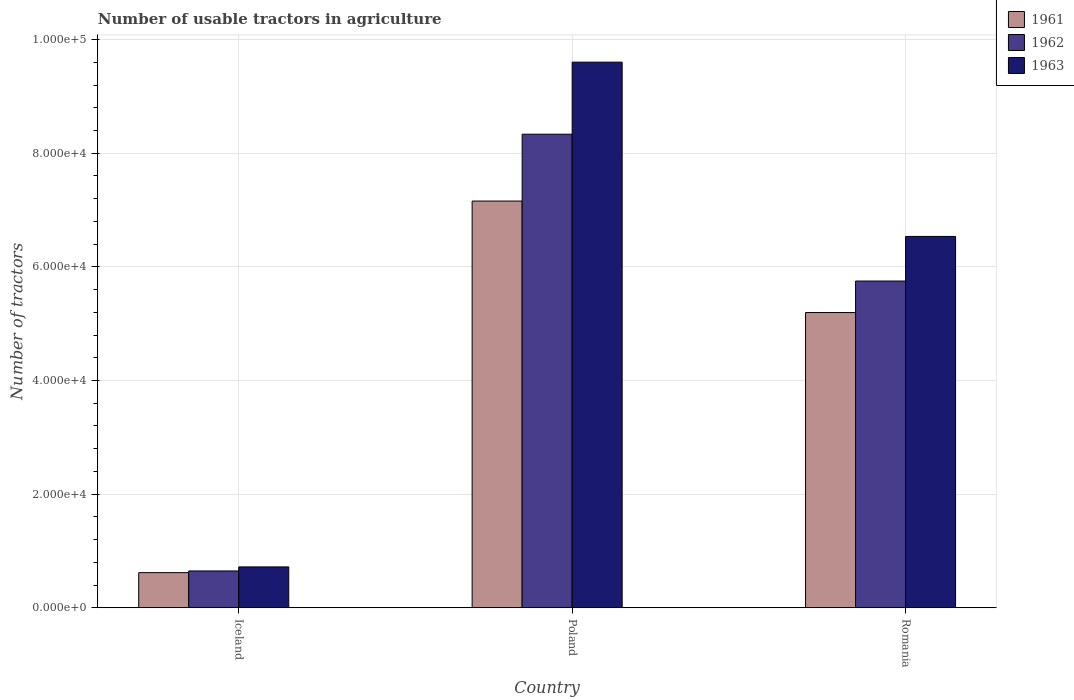Are the number of bars per tick equal to the number of legend labels?
Make the answer very short. Yes. Are the number of bars on each tick of the X-axis equal?
Give a very brief answer. Yes. How many bars are there on the 3rd tick from the left?
Offer a very short reply. 3. What is the label of the 3rd group of bars from the left?
Provide a succinct answer. Romania. What is the number of usable tractors in agriculture in 1963 in Poland?
Your answer should be compact. 9.60e+04. Across all countries, what is the maximum number of usable tractors in agriculture in 1963?
Make the answer very short. 9.60e+04. Across all countries, what is the minimum number of usable tractors in agriculture in 1963?
Your response must be concise. 7187. In which country was the number of usable tractors in agriculture in 1963 maximum?
Provide a succinct answer. Poland. In which country was the number of usable tractors in agriculture in 1961 minimum?
Make the answer very short. Iceland. What is the total number of usable tractors in agriculture in 1962 in the graph?
Your response must be concise. 1.47e+05. What is the difference between the number of usable tractors in agriculture in 1963 in Iceland and that in Poland?
Offer a very short reply. -8.88e+04. What is the difference between the number of usable tractors in agriculture in 1963 in Poland and the number of usable tractors in agriculture in 1961 in Romania?
Offer a very short reply. 4.41e+04. What is the average number of usable tractors in agriculture in 1962 per country?
Give a very brief answer. 4.91e+04. What is the difference between the number of usable tractors in agriculture of/in 1963 and number of usable tractors in agriculture of/in 1962 in Romania?
Make the answer very short. 7851. What is the ratio of the number of usable tractors in agriculture in 1963 in Poland to that in Romania?
Your answer should be compact. 1.47. Is the number of usable tractors in agriculture in 1963 in Iceland less than that in Poland?
Your response must be concise. Yes. Is the difference between the number of usable tractors in agriculture in 1963 in Poland and Romania greater than the difference between the number of usable tractors in agriculture in 1962 in Poland and Romania?
Give a very brief answer. Yes. What is the difference between the highest and the second highest number of usable tractors in agriculture in 1963?
Your answer should be very brief. -8.88e+04. What is the difference between the highest and the lowest number of usable tractors in agriculture in 1961?
Ensure brevity in your answer.  6.54e+04. Is the sum of the number of usable tractors in agriculture in 1962 in Iceland and Romania greater than the maximum number of usable tractors in agriculture in 1963 across all countries?
Your answer should be compact. No. Are all the bars in the graph horizontal?
Your response must be concise. No. How many countries are there in the graph?
Offer a terse response. 3. What is the difference between two consecutive major ticks on the Y-axis?
Give a very brief answer. 2.00e+04. Are the values on the major ticks of Y-axis written in scientific E-notation?
Make the answer very short. Yes. Does the graph contain grids?
Your answer should be compact. Yes. Where does the legend appear in the graph?
Your answer should be compact. Top right. How many legend labels are there?
Your answer should be compact. 3. What is the title of the graph?
Ensure brevity in your answer.  Number of usable tractors in agriculture. What is the label or title of the X-axis?
Make the answer very short. Country. What is the label or title of the Y-axis?
Provide a succinct answer. Number of tractors. What is the Number of tractors in 1961 in Iceland?
Your answer should be compact. 6177. What is the Number of tractors of 1962 in Iceland?
Offer a terse response. 6479. What is the Number of tractors of 1963 in Iceland?
Make the answer very short. 7187. What is the Number of tractors in 1961 in Poland?
Give a very brief answer. 7.16e+04. What is the Number of tractors in 1962 in Poland?
Your response must be concise. 8.33e+04. What is the Number of tractors of 1963 in Poland?
Ensure brevity in your answer.  9.60e+04. What is the Number of tractors in 1961 in Romania?
Keep it short and to the point. 5.20e+04. What is the Number of tractors of 1962 in Romania?
Ensure brevity in your answer.  5.75e+04. What is the Number of tractors of 1963 in Romania?
Keep it short and to the point. 6.54e+04. Across all countries, what is the maximum Number of tractors of 1961?
Your answer should be very brief. 7.16e+04. Across all countries, what is the maximum Number of tractors in 1962?
Make the answer very short. 8.33e+04. Across all countries, what is the maximum Number of tractors of 1963?
Your answer should be very brief. 9.60e+04. Across all countries, what is the minimum Number of tractors of 1961?
Keep it short and to the point. 6177. Across all countries, what is the minimum Number of tractors of 1962?
Make the answer very short. 6479. Across all countries, what is the minimum Number of tractors in 1963?
Keep it short and to the point. 7187. What is the total Number of tractors in 1961 in the graph?
Give a very brief answer. 1.30e+05. What is the total Number of tractors in 1962 in the graph?
Your response must be concise. 1.47e+05. What is the total Number of tractors of 1963 in the graph?
Provide a succinct answer. 1.69e+05. What is the difference between the Number of tractors of 1961 in Iceland and that in Poland?
Your answer should be very brief. -6.54e+04. What is the difference between the Number of tractors of 1962 in Iceland and that in Poland?
Give a very brief answer. -7.69e+04. What is the difference between the Number of tractors of 1963 in Iceland and that in Poland?
Provide a short and direct response. -8.88e+04. What is the difference between the Number of tractors of 1961 in Iceland and that in Romania?
Your answer should be compact. -4.58e+04. What is the difference between the Number of tractors in 1962 in Iceland and that in Romania?
Provide a succinct answer. -5.10e+04. What is the difference between the Number of tractors of 1963 in Iceland and that in Romania?
Provide a short and direct response. -5.82e+04. What is the difference between the Number of tractors of 1961 in Poland and that in Romania?
Your response must be concise. 1.96e+04. What is the difference between the Number of tractors in 1962 in Poland and that in Romania?
Your answer should be compact. 2.58e+04. What is the difference between the Number of tractors in 1963 in Poland and that in Romania?
Offer a terse response. 3.07e+04. What is the difference between the Number of tractors in 1961 in Iceland and the Number of tractors in 1962 in Poland?
Your response must be concise. -7.72e+04. What is the difference between the Number of tractors of 1961 in Iceland and the Number of tractors of 1963 in Poland?
Keep it short and to the point. -8.98e+04. What is the difference between the Number of tractors in 1962 in Iceland and the Number of tractors in 1963 in Poland?
Your answer should be very brief. -8.95e+04. What is the difference between the Number of tractors of 1961 in Iceland and the Number of tractors of 1962 in Romania?
Keep it short and to the point. -5.13e+04. What is the difference between the Number of tractors in 1961 in Iceland and the Number of tractors in 1963 in Romania?
Your answer should be very brief. -5.92e+04. What is the difference between the Number of tractors of 1962 in Iceland and the Number of tractors of 1963 in Romania?
Provide a short and direct response. -5.89e+04. What is the difference between the Number of tractors of 1961 in Poland and the Number of tractors of 1962 in Romania?
Your answer should be compact. 1.41e+04. What is the difference between the Number of tractors in 1961 in Poland and the Number of tractors in 1963 in Romania?
Offer a very short reply. 6226. What is the difference between the Number of tractors in 1962 in Poland and the Number of tractors in 1963 in Romania?
Offer a terse response. 1.80e+04. What is the average Number of tractors of 1961 per country?
Ensure brevity in your answer.  4.32e+04. What is the average Number of tractors of 1962 per country?
Provide a short and direct response. 4.91e+04. What is the average Number of tractors of 1963 per country?
Ensure brevity in your answer.  5.62e+04. What is the difference between the Number of tractors of 1961 and Number of tractors of 1962 in Iceland?
Keep it short and to the point. -302. What is the difference between the Number of tractors in 1961 and Number of tractors in 1963 in Iceland?
Offer a very short reply. -1010. What is the difference between the Number of tractors of 1962 and Number of tractors of 1963 in Iceland?
Make the answer very short. -708. What is the difference between the Number of tractors of 1961 and Number of tractors of 1962 in Poland?
Offer a very short reply. -1.18e+04. What is the difference between the Number of tractors in 1961 and Number of tractors in 1963 in Poland?
Your response must be concise. -2.44e+04. What is the difference between the Number of tractors in 1962 and Number of tractors in 1963 in Poland?
Ensure brevity in your answer.  -1.27e+04. What is the difference between the Number of tractors in 1961 and Number of tractors in 1962 in Romania?
Your answer should be compact. -5548. What is the difference between the Number of tractors of 1961 and Number of tractors of 1963 in Romania?
Offer a terse response. -1.34e+04. What is the difference between the Number of tractors in 1962 and Number of tractors in 1963 in Romania?
Your answer should be compact. -7851. What is the ratio of the Number of tractors in 1961 in Iceland to that in Poland?
Provide a short and direct response. 0.09. What is the ratio of the Number of tractors of 1962 in Iceland to that in Poland?
Your answer should be very brief. 0.08. What is the ratio of the Number of tractors of 1963 in Iceland to that in Poland?
Offer a very short reply. 0.07. What is the ratio of the Number of tractors of 1961 in Iceland to that in Romania?
Give a very brief answer. 0.12. What is the ratio of the Number of tractors in 1962 in Iceland to that in Romania?
Give a very brief answer. 0.11. What is the ratio of the Number of tractors of 1963 in Iceland to that in Romania?
Your answer should be very brief. 0.11. What is the ratio of the Number of tractors of 1961 in Poland to that in Romania?
Offer a very short reply. 1.38. What is the ratio of the Number of tractors of 1962 in Poland to that in Romania?
Your response must be concise. 1.45. What is the ratio of the Number of tractors in 1963 in Poland to that in Romania?
Offer a very short reply. 1.47. What is the difference between the highest and the second highest Number of tractors in 1961?
Provide a short and direct response. 1.96e+04. What is the difference between the highest and the second highest Number of tractors of 1962?
Your response must be concise. 2.58e+04. What is the difference between the highest and the second highest Number of tractors of 1963?
Make the answer very short. 3.07e+04. What is the difference between the highest and the lowest Number of tractors in 1961?
Keep it short and to the point. 6.54e+04. What is the difference between the highest and the lowest Number of tractors of 1962?
Your answer should be compact. 7.69e+04. What is the difference between the highest and the lowest Number of tractors in 1963?
Ensure brevity in your answer.  8.88e+04. 